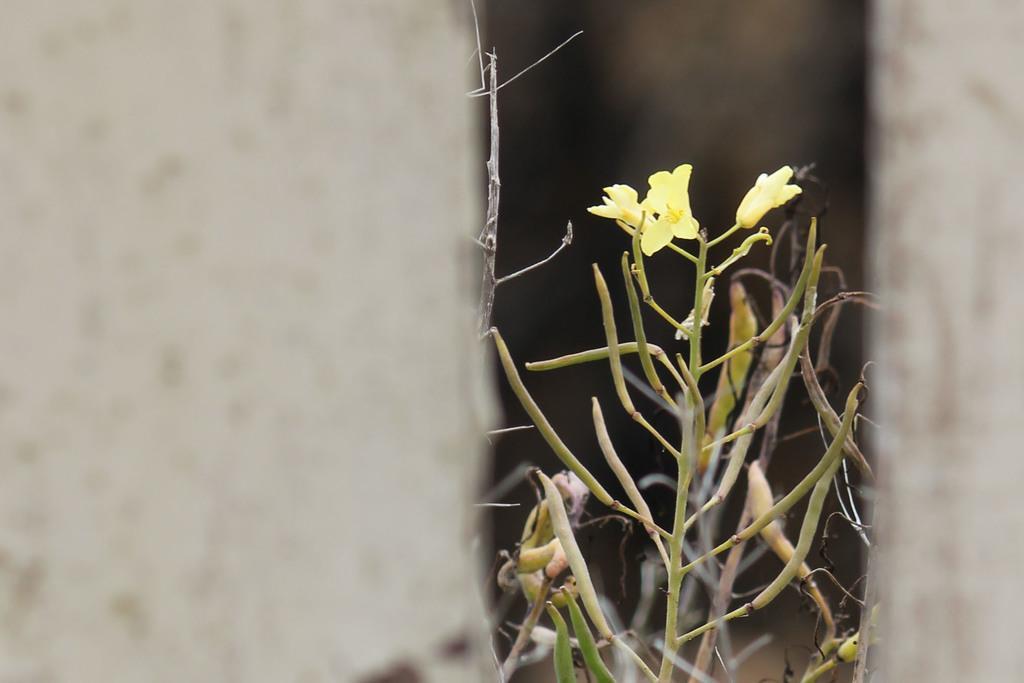How would you summarize this image in a sentence or two? In this image I can see plants, wall and so on. This image is taken may be during a day. 